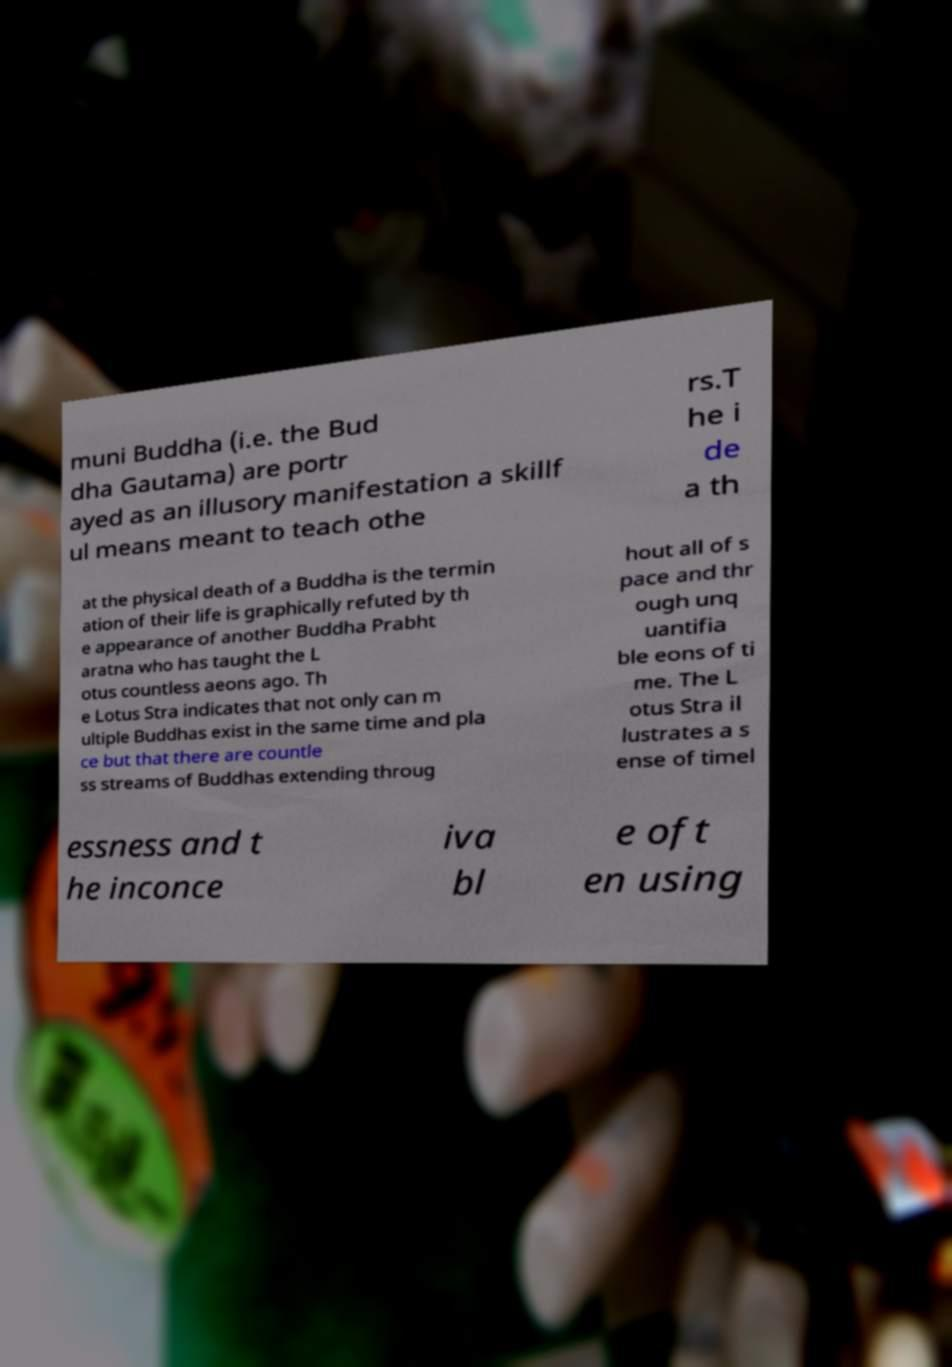There's text embedded in this image that I need extracted. Can you transcribe it verbatim? muni Buddha (i.e. the Bud dha Gautama) are portr ayed as an illusory manifestation a skillf ul means meant to teach othe rs.T he i de a th at the physical death of a Buddha is the termin ation of their life is graphically refuted by th e appearance of another Buddha Prabht aratna who has taught the L otus countless aeons ago. Th e Lotus Stra indicates that not only can m ultiple Buddhas exist in the same time and pla ce but that there are countle ss streams of Buddhas extending throug hout all of s pace and thr ough unq uantifia ble eons of ti me. The L otus Stra il lustrates a s ense of timel essness and t he inconce iva bl e oft en using 